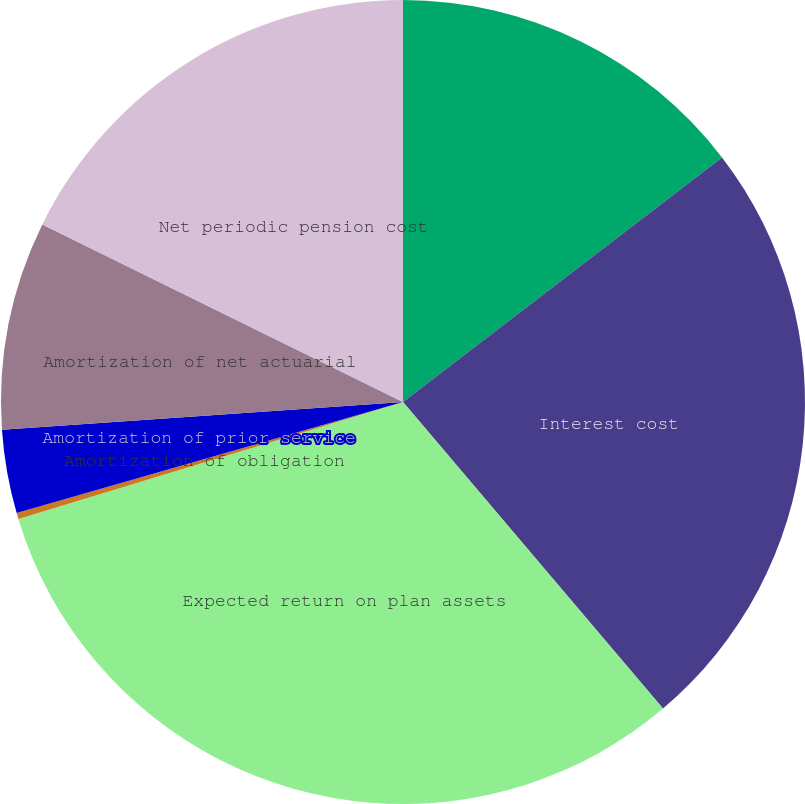Convert chart to OTSL. <chart><loc_0><loc_0><loc_500><loc_500><pie_chart><fcel>Service cost<fcel>Interest cost<fcel>Expected return on plan assets<fcel>Amortization of obligation<fcel>Amortization of prior service<fcel>Amortization of net actuarial<fcel>Net periodic pension cost<nl><fcel>14.59%<fcel>24.22%<fcel>31.5%<fcel>0.24%<fcel>3.36%<fcel>8.38%<fcel>17.72%<nl></chart> 